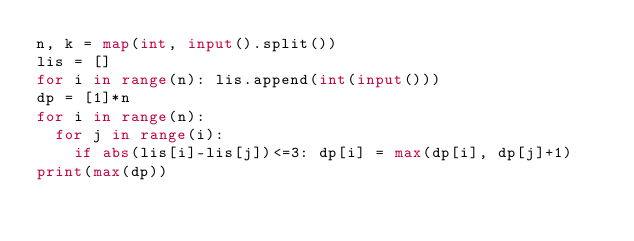Convert code to text. <code><loc_0><loc_0><loc_500><loc_500><_Python_>n, k = map(int, input().split())
lis = []
for i in range(n): lis.append(int(input()))
dp = [1]*n
for i in range(n):
  for j in range(i):
    if abs(lis[i]-lis[j])<=3: dp[i] = max(dp[i], dp[j]+1)
print(max(dp))
</code> 